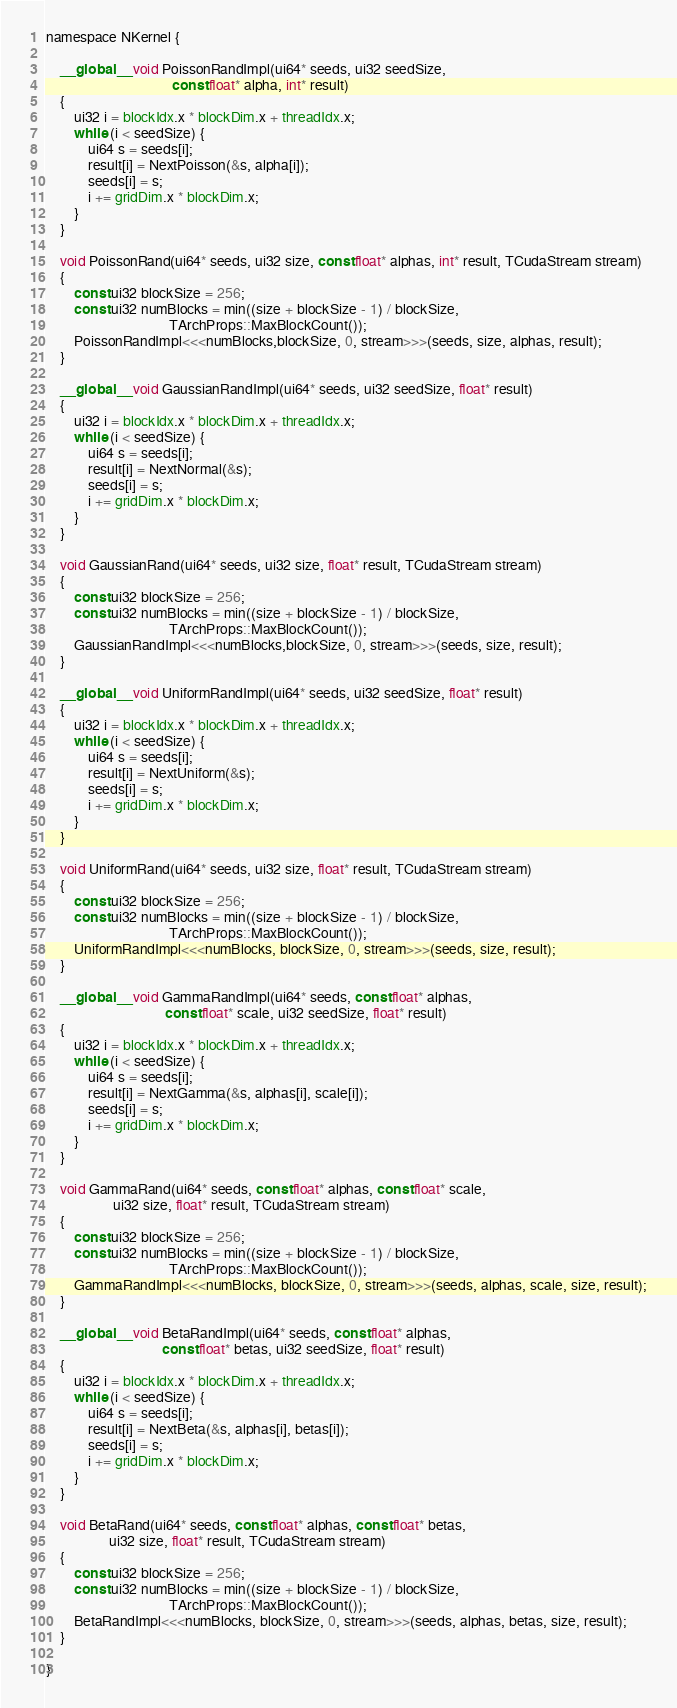<code> <loc_0><loc_0><loc_500><loc_500><_Cuda_>
namespace NKernel {

    __global__ void PoissonRandImpl(ui64* seeds, ui32 seedSize,
                                    const float* alpha, int* result)
    {
        ui32 i = blockIdx.x * blockDim.x + threadIdx.x;
        while (i < seedSize) {
            ui64 s = seeds[i];
            result[i] = NextPoisson(&s, alpha[i]);
            seeds[i] = s;
            i += gridDim.x * blockDim.x;
        }
    }

    void PoissonRand(ui64* seeds, ui32 size, const float* alphas, int* result, TCudaStream stream)
    {
        const ui32 blockSize = 256;
        const ui32 numBlocks = min((size + blockSize - 1) / blockSize,
                                   TArchProps::MaxBlockCount());
        PoissonRandImpl<<<numBlocks,blockSize, 0, stream>>>(seeds, size, alphas, result);
    }

    __global__ void GaussianRandImpl(ui64* seeds, ui32 seedSize, float* result)
    {
        ui32 i = blockIdx.x * blockDim.x + threadIdx.x;
        while (i < seedSize) {
            ui64 s = seeds[i];
            result[i] = NextNormal(&s);
            seeds[i] = s;
            i += gridDim.x * blockDim.x;
        }
    }

    void GaussianRand(ui64* seeds, ui32 size, float* result, TCudaStream stream)
    {
        const ui32 blockSize = 256;
        const ui32 numBlocks = min((size + blockSize - 1) / blockSize,
                                   TArchProps::MaxBlockCount());
        GaussianRandImpl<<<numBlocks,blockSize, 0, stream>>>(seeds, size, result);
    }

    __global__ void UniformRandImpl(ui64* seeds, ui32 seedSize, float* result)
    {
        ui32 i = blockIdx.x * blockDim.x + threadIdx.x;
        while (i < seedSize) {
            ui64 s = seeds[i];
            result[i] = NextUniform(&s);
            seeds[i] = s;
            i += gridDim.x * blockDim.x;
        }
    }

    void UniformRand(ui64* seeds, ui32 size, float* result, TCudaStream stream)
    {
        const ui32 blockSize = 256;
        const ui32 numBlocks = min((size + blockSize - 1) / blockSize,
                                   TArchProps::MaxBlockCount());
        UniformRandImpl<<<numBlocks, blockSize, 0, stream>>>(seeds, size, result);
    }

    __global__ void GammaRandImpl(ui64* seeds, const float* alphas,
                                  const float* scale, ui32 seedSize, float* result)
    {
        ui32 i = blockIdx.x * blockDim.x + threadIdx.x;
        while (i < seedSize) {
            ui64 s = seeds[i];
            result[i] = NextGamma(&s, alphas[i], scale[i]);
            seeds[i] = s;
            i += gridDim.x * blockDim.x;
        }
    }

    void GammaRand(ui64* seeds, const float* alphas, const float* scale,
                   ui32 size, float* result, TCudaStream stream)
    {
        const ui32 blockSize = 256;
        const ui32 numBlocks = min((size + blockSize - 1) / blockSize,
                                   TArchProps::MaxBlockCount());
        GammaRandImpl<<<numBlocks, blockSize, 0, stream>>>(seeds, alphas, scale, size, result);
    }

    __global__ void BetaRandImpl(ui64* seeds, const float* alphas,
                                 const float* betas, ui32 seedSize, float* result)
    {
        ui32 i = blockIdx.x * blockDim.x + threadIdx.x;
        while (i < seedSize) {
            ui64 s = seeds[i];
            result[i] = NextBeta(&s, alphas[i], betas[i]);
            seeds[i] = s;
            i += gridDim.x * blockDim.x;
        }
    }

    void BetaRand(ui64* seeds, const float* alphas, const float* betas,
                  ui32 size, float* result, TCudaStream stream)
    {
        const ui32 blockSize = 256;
        const ui32 numBlocks = min((size + blockSize - 1) / blockSize,
                                   TArchProps::MaxBlockCount());
        BetaRandImpl<<<numBlocks, blockSize, 0, stream>>>(seeds, alphas, betas, size, result);
    }

}
</code> 